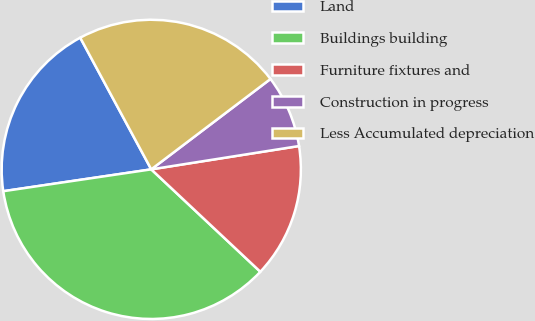Convert chart. <chart><loc_0><loc_0><loc_500><loc_500><pie_chart><fcel>Land<fcel>Buildings building<fcel>Furniture fixtures and<fcel>Construction in progress<fcel>Less Accumulated depreciation<nl><fcel>19.46%<fcel>35.67%<fcel>14.49%<fcel>7.83%<fcel>22.55%<nl></chart> 